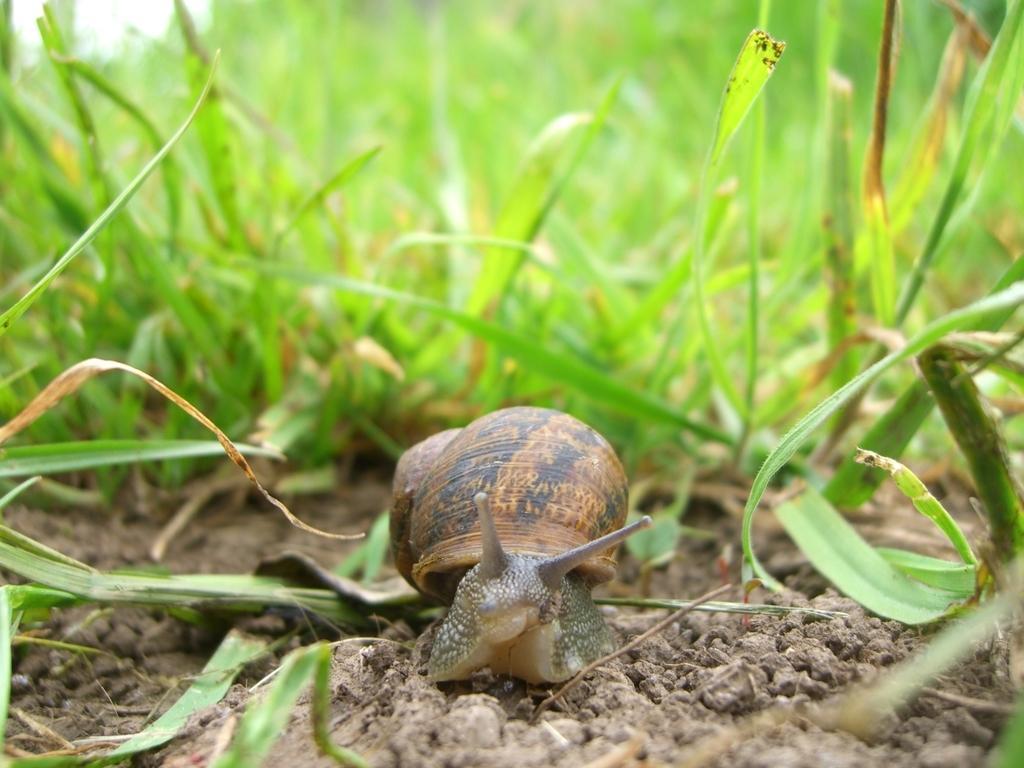Please provide a concise description of this image. In this image I can see a snail which is green and cream in color and a shell which is brown and black in color. I can see the ground and some grass. In the background I can see the sky. 